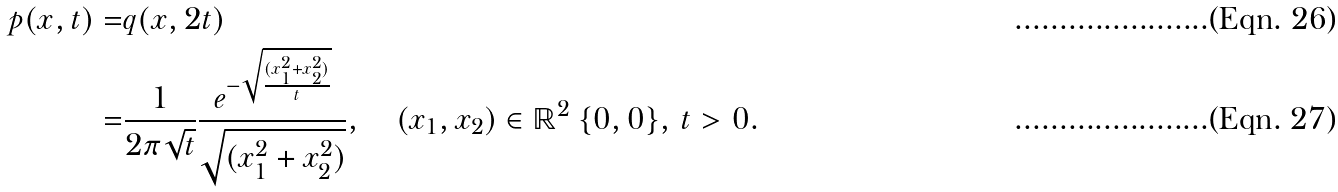<formula> <loc_0><loc_0><loc_500><loc_500>p ( x , t ) = & q ( x , 2 t ) \\ = & \frac { 1 } { 2 \pi \sqrt { t } } \frac { e ^ { - \sqrt { \frac { ( x _ { 1 } ^ { 2 } + x _ { 2 } ^ { 2 } ) } { t } } } } { \sqrt { ( x _ { 1 } ^ { 2 } + x _ { 2 } ^ { 2 } ) } } , \quad ( x _ { 1 } , x _ { 2 } ) \in \mathbb { R } ^ { 2 } \ \{ 0 , 0 \} , \, t > 0 .</formula> 